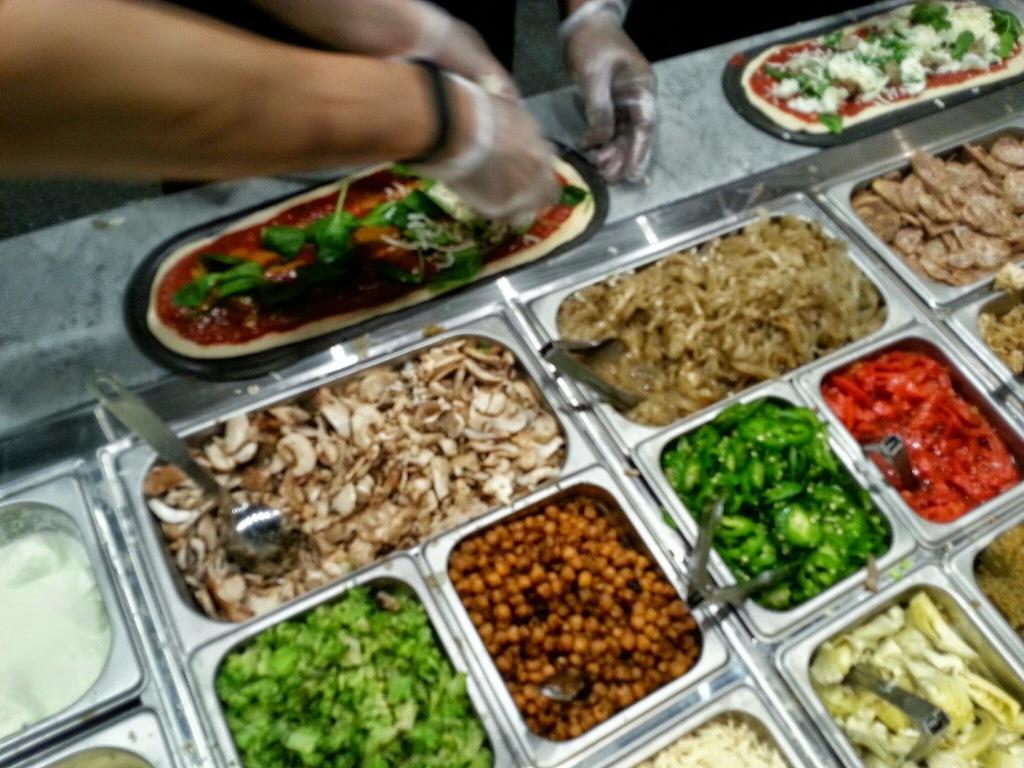Can you describe this image briefly? In this image we can see food items in food containers. We can see persons hands with gloves. 